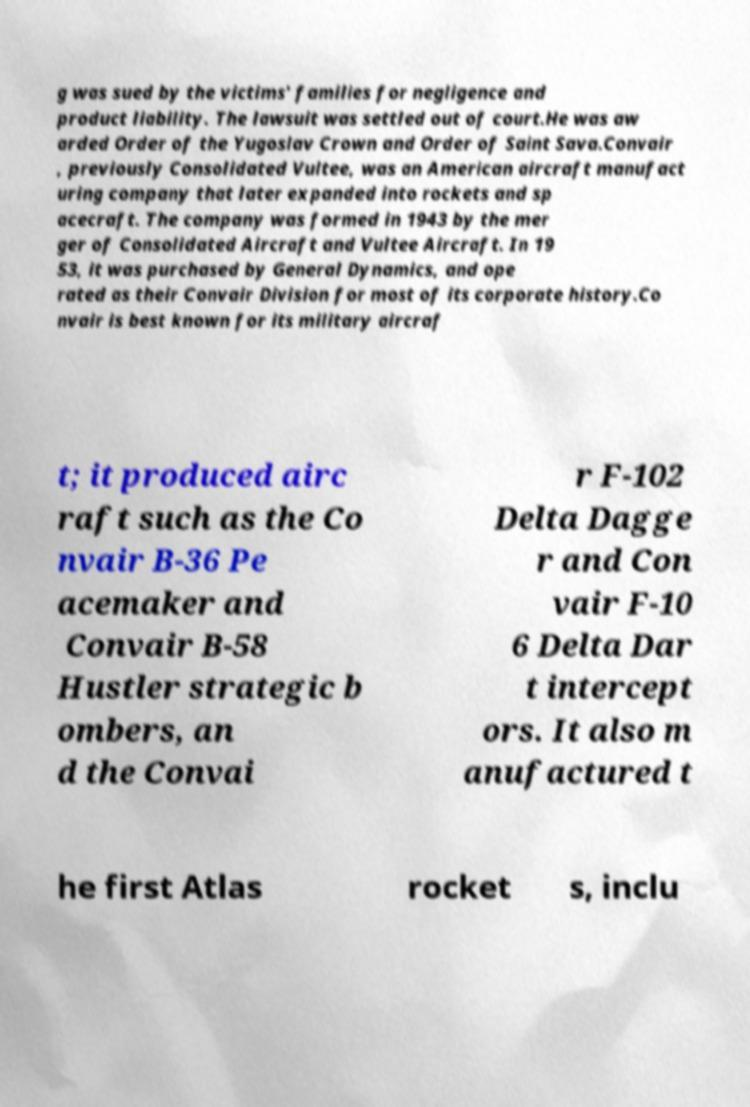There's text embedded in this image that I need extracted. Can you transcribe it verbatim? g was sued by the victims' families for negligence and product liability. The lawsuit was settled out of court.He was aw arded Order of the Yugoslav Crown and Order of Saint Sava.Convair , previously Consolidated Vultee, was an American aircraft manufact uring company that later expanded into rockets and sp acecraft. The company was formed in 1943 by the mer ger of Consolidated Aircraft and Vultee Aircraft. In 19 53, it was purchased by General Dynamics, and ope rated as their Convair Division for most of its corporate history.Co nvair is best known for its military aircraf t; it produced airc raft such as the Co nvair B-36 Pe acemaker and Convair B-58 Hustler strategic b ombers, an d the Convai r F-102 Delta Dagge r and Con vair F-10 6 Delta Dar t intercept ors. It also m anufactured t he first Atlas rocket s, inclu 